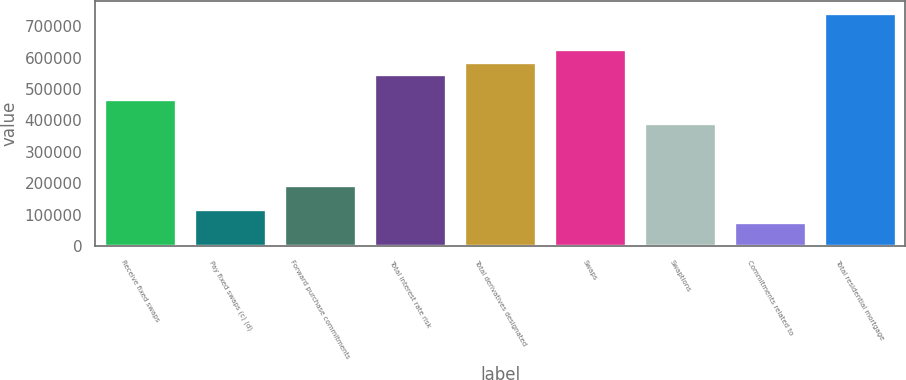Convert chart. <chart><loc_0><loc_0><loc_500><loc_500><bar_chart><fcel>Receive fixed swaps<fcel>Pay fixed swaps (c) (d)<fcel>Forward purchase commitments<fcel>Total interest rate risk<fcel>Total derivatives designated<fcel>Swaps<fcel>Swaptions<fcel>Commitments related to<fcel>Total residential mortgage<nl><fcel>469576<fcel>117465<fcel>195712<fcel>547823<fcel>586946<fcel>626069<fcel>391329<fcel>78341.8<fcel>743440<nl></chart> 